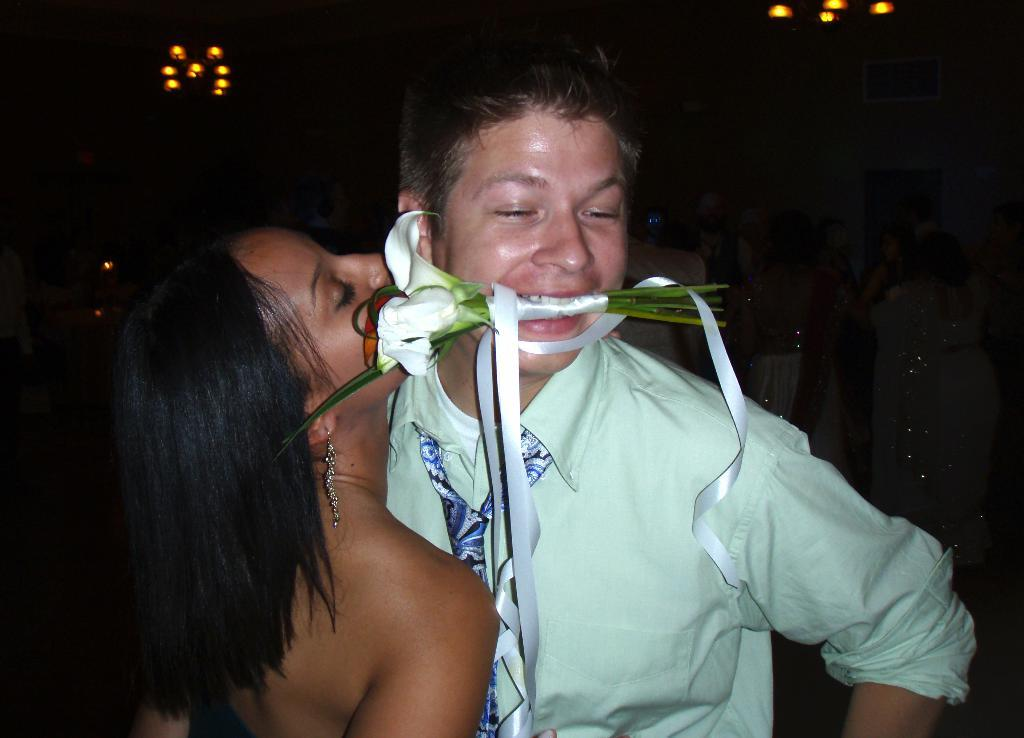What is happening in the image? There are people standing in the image, and a man is holding a flower bouquet in his mouth. Can you describe the man's attire? The man is wearing a tie. What type of soap is being used by the people in the image? There is no soap present in the image. How does the texture of the payment method feel in the image? There is no payment method present in the image. 